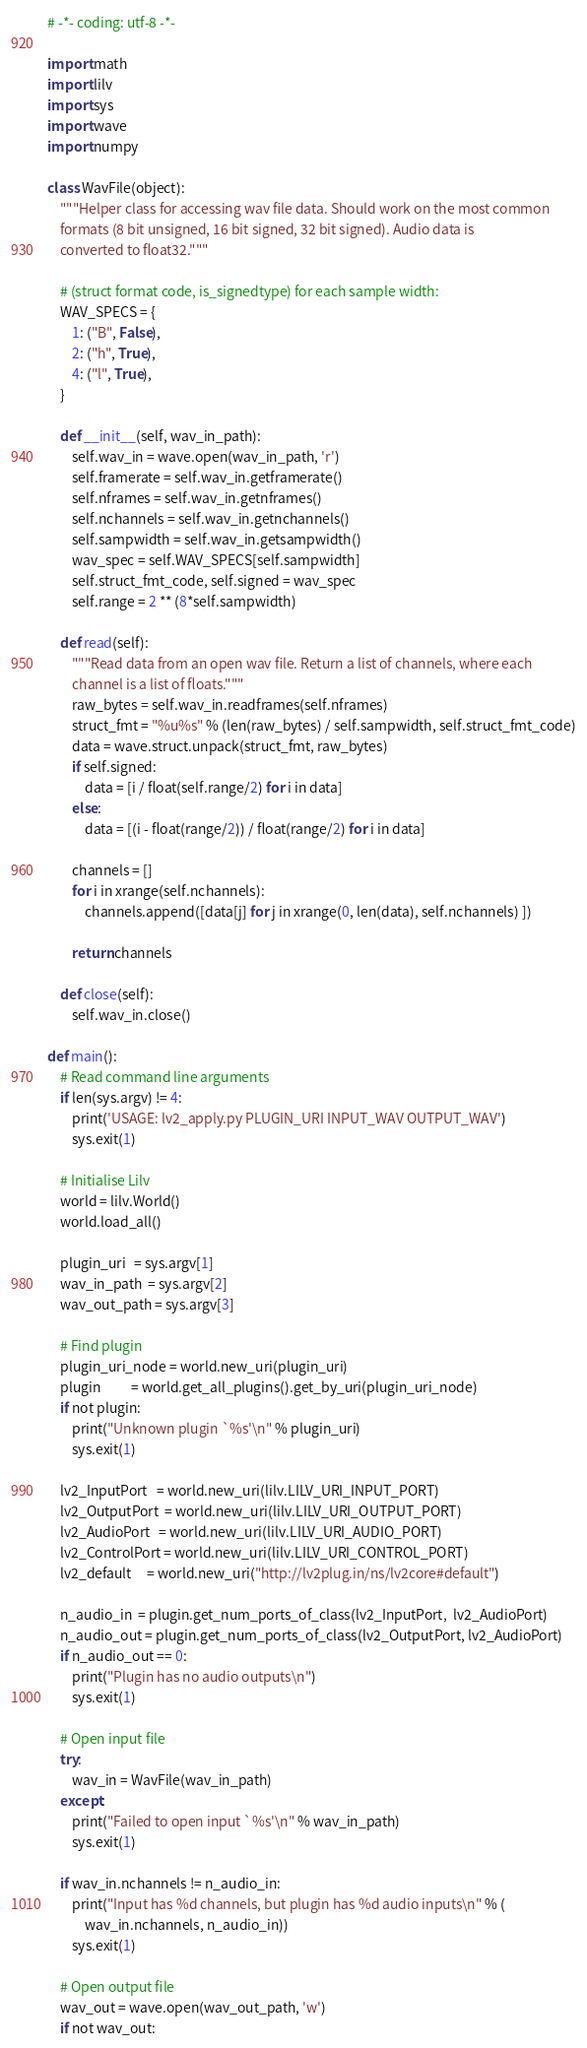<code> <loc_0><loc_0><loc_500><loc_500><_Python_># -*- coding: utf-8 -*-

import math
import lilv
import sys
import wave
import numpy

class WavFile(object):
    """Helper class for accessing wav file data. Should work on the most common
    formats (8 bit unsigned, 16 bit signed, 32 bit signed). Audio data is
    converted to float32."""

    # (struct format code, is_signedtype) for each sample width:
    WAV_SPECS = {
        1: ("B", False),
        2: ("h", True),
        4: ("l", True),
    }

    def __init__(self, wav_in_path):
        self.wav_in = wave.open(wav_in_path, 'r')
        self.framerate = self.wav_in.getframerate()
        self.nframes = self.wav_in.getnframes()
        self.nchannels = self.wav_in.getnchannels()
        self.sampwidth = self.wav_in.getsampwidth()
        wav_spec = self.WAV_SPECS[self.sampwidth]
        self.struct_fmt_code, self.signed = wav_spec
        self.range = 2 ** (8*self.sampwidth)

    def read(self):
        """Read data from an open wav file. Return a list of channels, where each
        channel is a list of floats."""
        raw_bytes = self.wav_in.readframes(self.nframes)
        struct_fmt = "%u%s" % (len(raw_bytes) / self.sampwidth, self.struct_fmt_code)
        data = wave.struct.unpack(struct_fmt, raw_bytes)
        if self.signed:
            data = [i / float(self.range/2) for i in data]
        else:
            data = [(i - float(range/2)) / float(range/2) for i in data]

        channels = []
        for i in xrange(self.nchannels):
            channels.append([data[j] for j in xrange(0, len(data), self.nchannels) ])

        return channels

    def close(self):
        self.wav_in.close()

def main():
    # Read command line arguments
    if len(sys.argv) != 4:
        print('USAGE: lv2_apply.py PLUGIN_URI INPUT_WAV OUTPUT_WAV')
        sys.exit(1)

    # Initialise Lilv
    world = lilv.World()
    world.load_all()

    plugin_uri   = sys.argv[1]
    wav_in_path  = sys.argv[2]
    wav_out_path = sys.argv[3]

    # Find plugin
    plugin_uri_node = world.new_uri(plugin_uri)
    plugin          = world.get_all_plugins().get_by_uri(plugin_uri_node)
    if not plugin:
        print("Unknown plugin `%s'\n" % plugin_uri)
        sys.exit(1)

    lv2_InputPort   = world.new_uri(lilv.LILV_URI_INPUT_PORT)
    lv2_OutputPort  = world.new_uri(lilv.LILV_URI_OUTPUT_PORT)
    lv2_AudioPort   = world.new_uri(lilv.LILV_URI_AUDIO_PORT)
    lv2_ControlPort = world.new_uri(lilv.LILV_URI_CONTROL_PORT)
    lv2_default     = world.new_uri("http://lv2plug.in/ns/lv2core#default")

    n_audio_in  = plugin.get_num_ports_of_class(lv2_InputPort,  lv2_AudioPort)
    n_audio_out = plugin.get_num_ports_of_class(lv2_OutputPort, lv2_AudioPort)
    if n_audio_out == 0:
        print("Plugin has no audio outputs\n")
        sys.exit(1)

    # Open input file
    try:
        wav_in = WavFile(wav_in_path)
    except:
        print("Failed to open input `%s'\n" % wav_in_path)
        sys.exit(1)

    if wav_in.nchannels != n_audio_in:
        print("Input has %d channels, but plugin has %d audio inputs\n" % (
            wav_in.nchannels, n_audio_in))
        sys.exit(1)

    # Open output file
    wav_out = wave.open(wav_out_path, 'w')
    if not wav_out:</code> 